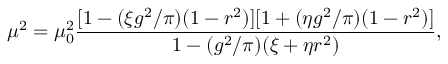<formula> <loc_0><loc_0><loc_500><loc_500>\mu ^ { 2 } = \mu _ { 0 } ^ { 2 } { \frac { [ 1 - ( \xi g ^ { 2 } / \pi ) ( 1 - r ^ { 2 } ) ] [ 1 + ( \eta g ^ { 2 } / \pi ) ( 1 - r ^ { 2 } ) ] } { 1 - ( g ^ { 2 } / \pi ) ( \xi + \eta r ^ { 2 } ) } } ,</formula> 